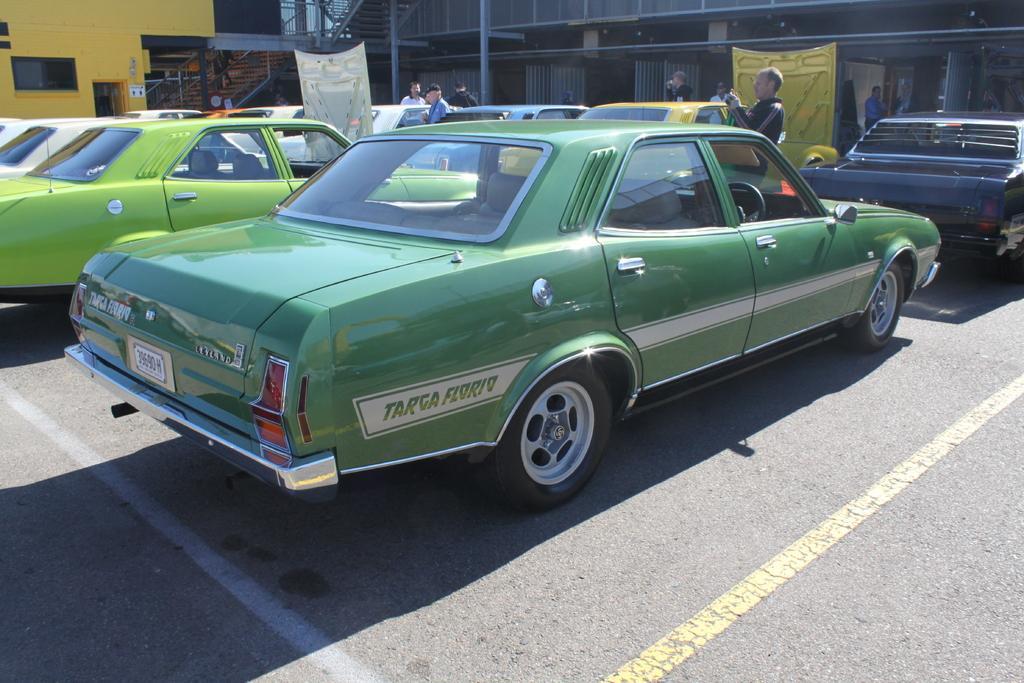Can you describe this image briefly? In the image there are many cars in the parking area. There are few people standing. In the background there is a wall and also there are steps with railings, poles and also there are walls. 